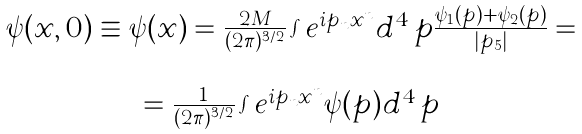<formula> <loc_0><loc_0><loc_500><loc_500>\begin{array} { c } \psi ( x , 0 ) \equiv \psi ( x ) = \frac { 2 M } { ( 2 \pi ) ^ { 3 / 2 } } \int e ^ { i p _ { n } x ^ { n } } d ^ { 4 } \, p \frac { \psi _ { 1 } ( p ) + \psi _ { 2 } ( p ) } { | p _ { 5 } | } = \\ \\ = \frac { 1 } { ( 2 \pi ) ^ { 3 / 2 } } \int e ^ { i p _ { n } x ^ { n } } \psi ( p ) d ^ { 4 } \, p \\ \end{array}</formula> 